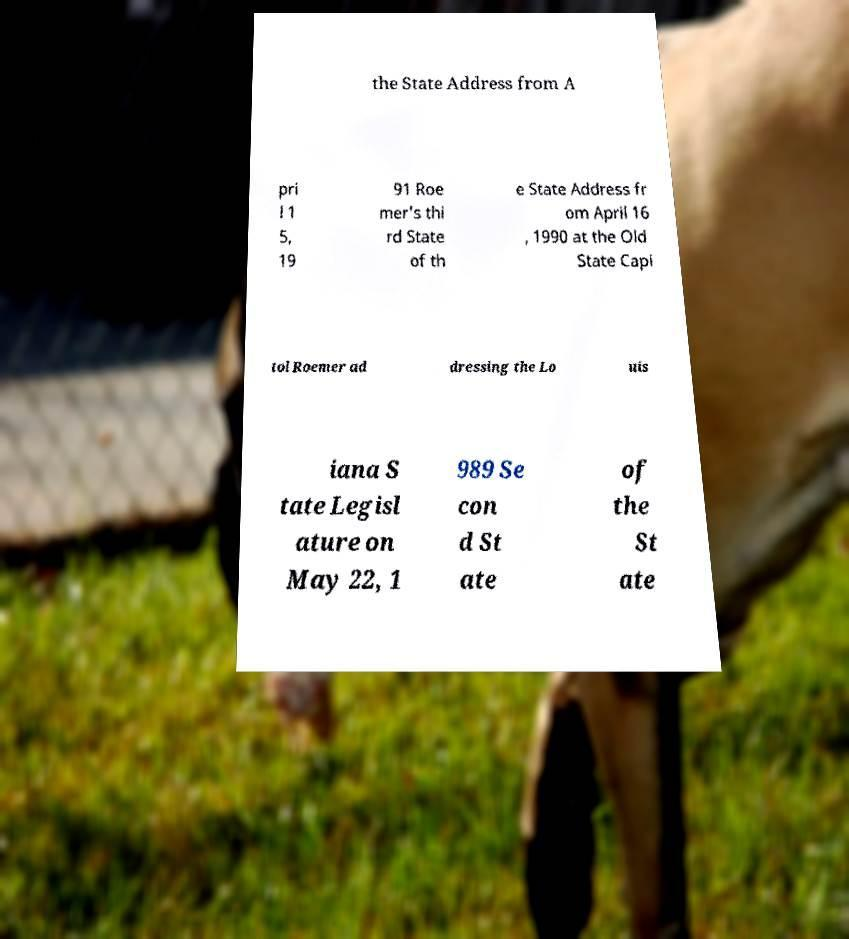For documentation purposes, I need the text within this image transcribed. Could you provide that? the State Address from A pri l 1 5, 19 91 Roe mer's thi rd State of th e State Address fr om April 16 , 1990 at the Old State Capi tol Roemer ad dressing the Lo uis iana S tate Legisl ature on May 22, 1 989 Se con d St ate of the St ate 